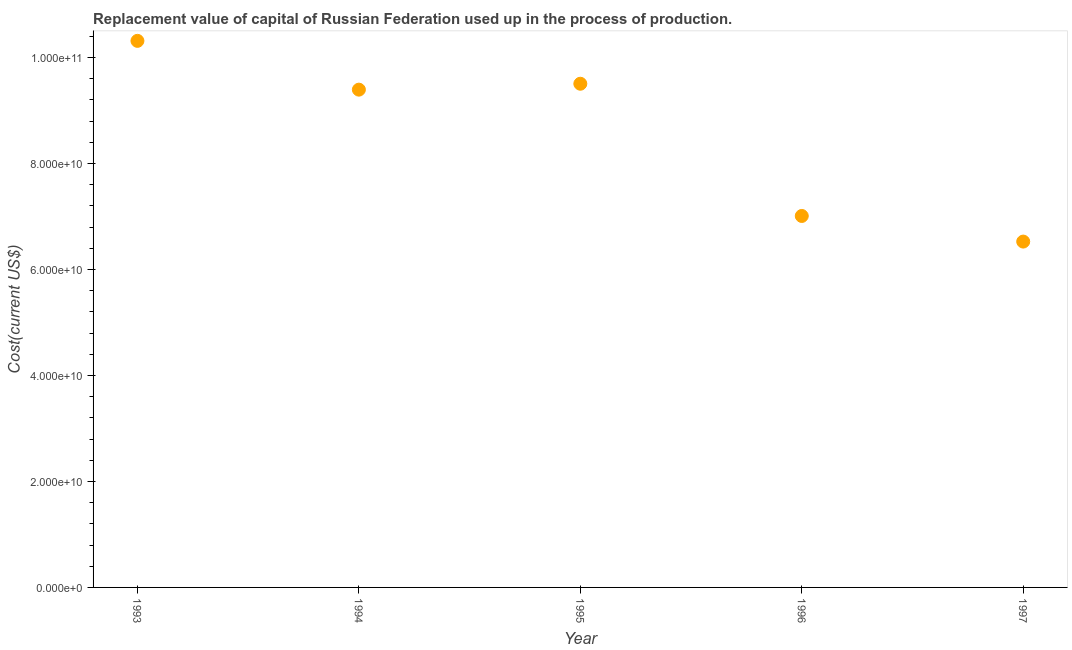What is the consumption of fixed capital in 1996?
Make the answer very short. 7.01e+1. Across all years, what is the maximum consumption of fixed capital?
Offer a terse response. 1.03e+11. Across all years, what is the minimum consumption of fixed capital?
Give a very brief answer. 6.53e+1. What is the sum of the consumption of fixed capital?
Make the answer very short. 4.27e+11. What is the difference between the consumption of fixed capital in 1993 and 1997?
Provide a succinct answer. 3.79e+1. What is the average consumption of fixed capital per year?
Ensure brevity in your answer.  8.55e+1. What is the median consumption of fixed capital?
Make the answer very short. 9.39e+1. What is the ratio of the consumption of fixed capital in 1993 to that in 1997?
Give a very brief answer. 1.58. Is the consumption of fixed capital in 1995 less than that in 1996?
Offer a terse response. No. Is the difference between the consumption of fixed capital in 1996 and 1997 greater than the difference between any two years?
Make the answer very short. No. What is the difference between the highest and the second highest consumption of fixed capital?
Provide a short and direct response. 8.09e+09. What is the difference between the highest and the lowest consumption of fixed capital?
Your answer should be compact. 3.79e+1. In how many years, is the consumption of fixed capital greater than the average consumption of fixed capital taken over all years?
Your answer should be compact. 3. Does the consumption of fixed capital monotonically increase over the years?
Offer a terse response. No. What is the difference between two consecutive major ticks on the Y-axis?
Ensure brevity in your answer.  2.00e+1. Are the values on the major ticks of Y-axis written in scientific E-notation?
Your response must be concise. Yes. Does the graph contain grids?
Your answer should be compact. No. What is the title of the graph?
Offer a terse response. Replacement value of capital of Russian Federation used up in the process of production. What is the label or title of the X-axis?
Offer a terse response. Year. What is the label or title of the Y-axis?
Offer a terse response. Cost(current US$). What is the Cost(current US$) in 1993?
Make the answer very short. 1.03e+11. What is the Cost(current US$) in 1994?
Your response must be concise. 9.39e+1. What is the Cost(current US$) in 1995?
Keep it short and to the point. 9.51e+1. What is the Cost(current US$) in 1996?
Provide a succinct answer. 7.01e+1. What is the Cost(current US$) in 1997?
Offer a very short reply. 6.53e+1. What is the difference between the Cost(current US$) in 1993 and 1994?
Provide a succinct answer. 9.21e+09. What is the difference between the Cost(current US$) in 1993 and 1995?
Ensure brevity in your answer.  8.09e+09. What is the difference between the Cost(current US$) in 1993 and 1996?
Offer a terse response. 3.30e+1. What is the difference between the Cost(current US$) in 1993 and 1997?
Keep it short and to the point. 3.79e+1. What is the difference between the Cost(current US$) in 1994 and 1995?
Give a very brief answer. -1.11e+09. What is the difference between the Cost(current US$) in 1994 and 1996?
Your answer should be compact. 2.38e+1. What is the difference between the Cost(current US$) in 1994 and 1997?
Give a very brief answer. 2.87e+1. What is the difference between the Cost(current US$) in 1995 and 1996?
Ensure brevity in your answer.  2.50e+1. What is the difference between the Cost(current US$) in 1995 and 1997?
Offer a very short reply. 2.98e+1. What is the difference between the Cost(current US$) in 1996 and 1997?
Your answer should be compact. 4.83e+09. What is the ratio of the Cost(current US$) in 1993 to that in 1994?
Ensure brevity in your answer.  1.1. What is the ratio of the Cost(current US$) in 1993 to that in 1995?
Keep it short and to the point. 1.08. What is the ratio of the Cost(current US$) in 1993 to that in 1996?
Your answer should be compact. 1.47. What is the ratio of the Cost(current US$) in 1993 to that in 1997?
Your response must be concise. 1.58. What is the ratio of the Cost(current US$) in 1994 to that in 1995?
Offer a very short reply. 0.99. What is the ratio of the Cost(current US$) in 1994 to that in 1996?
Your answer should be very brief. 1.34. What is the ratio of the Cost(current US$) in 1994 to that in 1997?
Your answer should be compact. 1.44. What is the ratio of the Cost(current US$) in 1995 to that in 1996?
Offer a very short reply. 1.36. What is the ratio of the Cost(current US$) in 1995 to that in 1997?
Give a very brief answer. 1.46. What is the ratio of the Cost(current US$) in 1996 to that in 1997?
Ensure brevity in your answer.  1.07. 